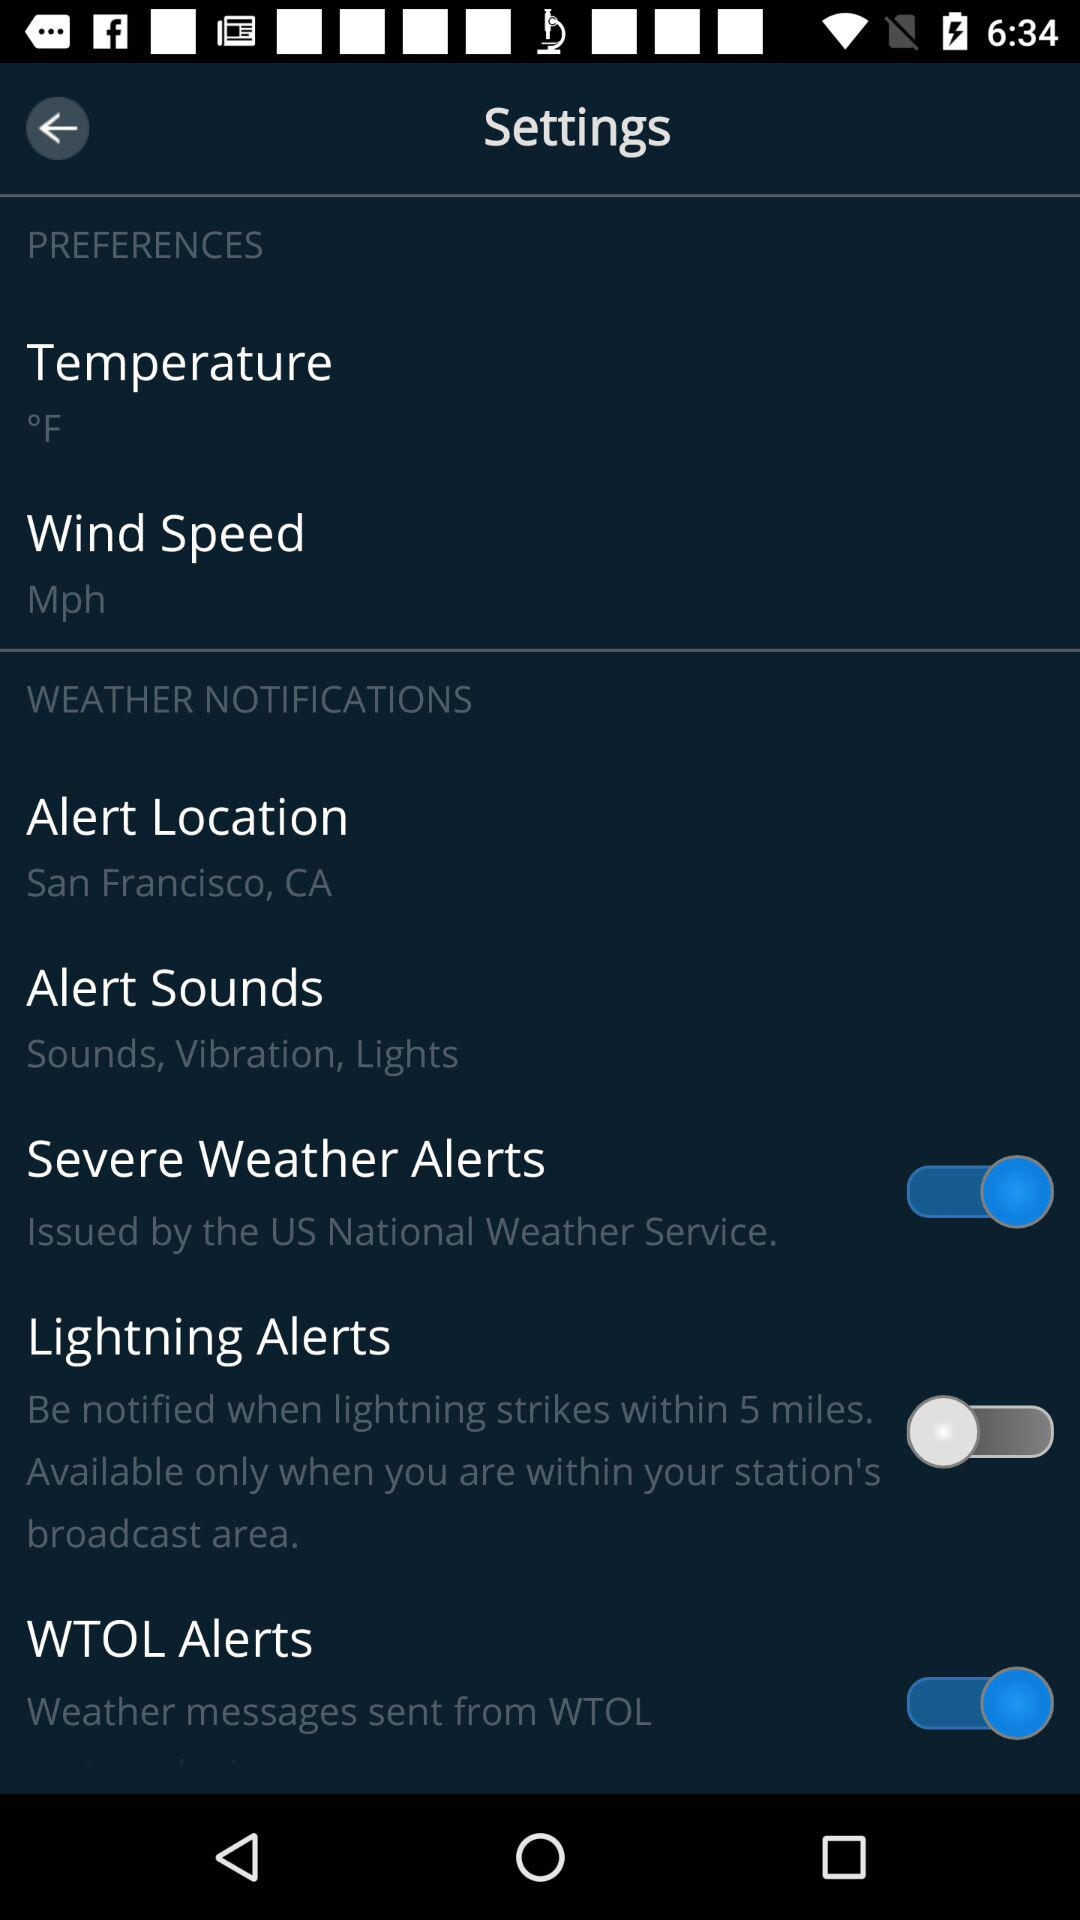What is the measuring unit of wind speed? The measuring unit is mph. 